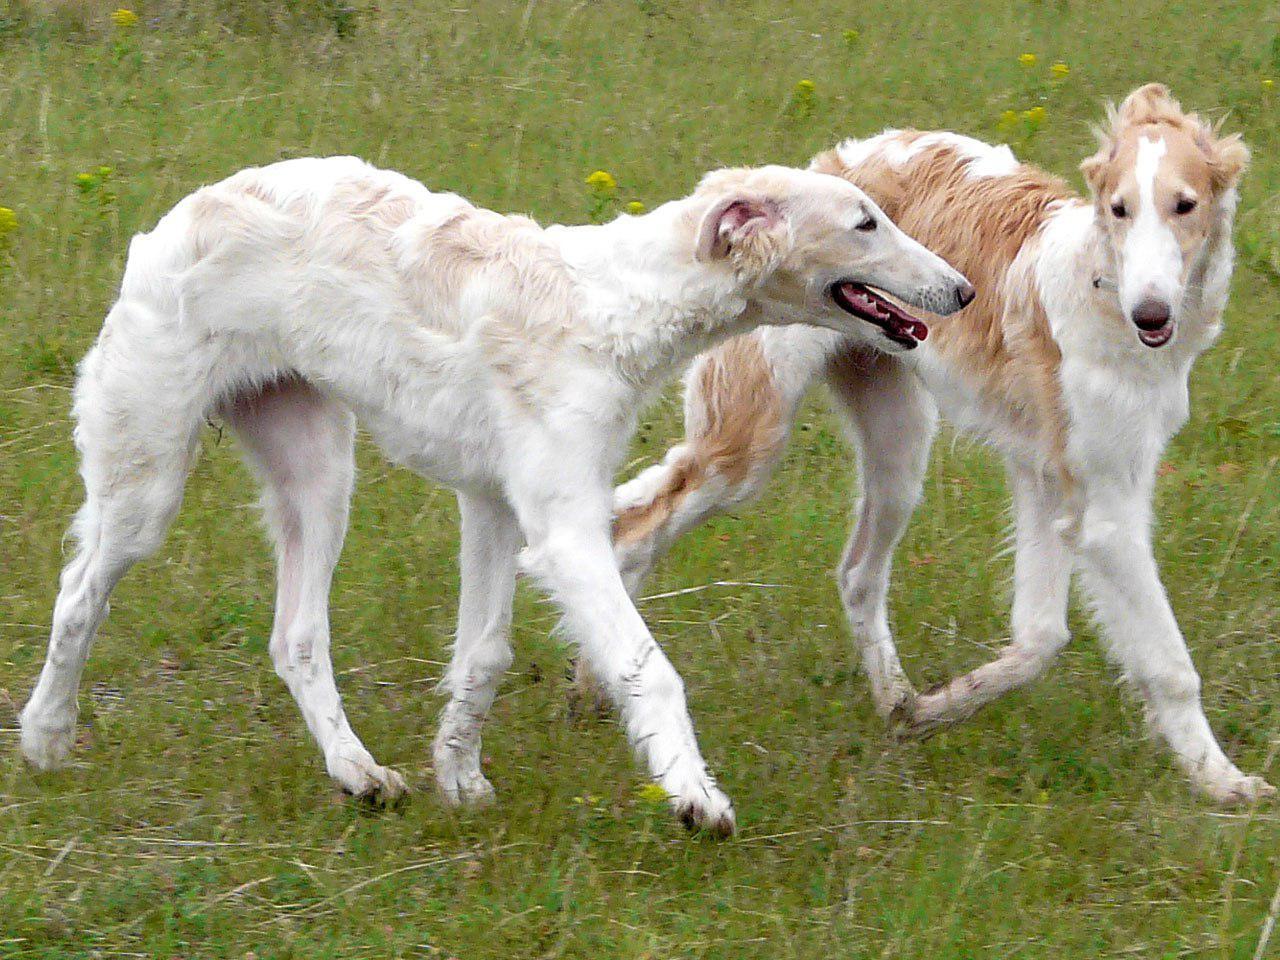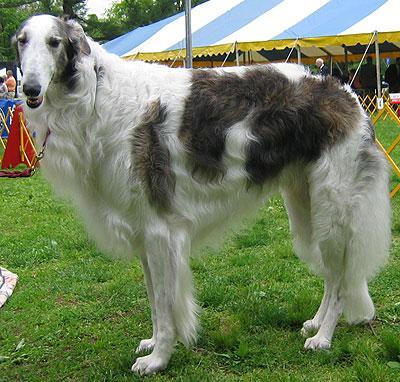The first image is the image on the left, the second image is the image on the right. Given the left and right images, does the statement "An image shows one hound standing in profile with body turned leftward, on green grass in front of a manmade structure." hold true? Answer yes or no. Yes. The first image is the image on the left, the second image is the image on the right. Analyze the images presented: Is the assertion "Three dogs are standing in the green grass." valid? Answer yes or no. Yes. 